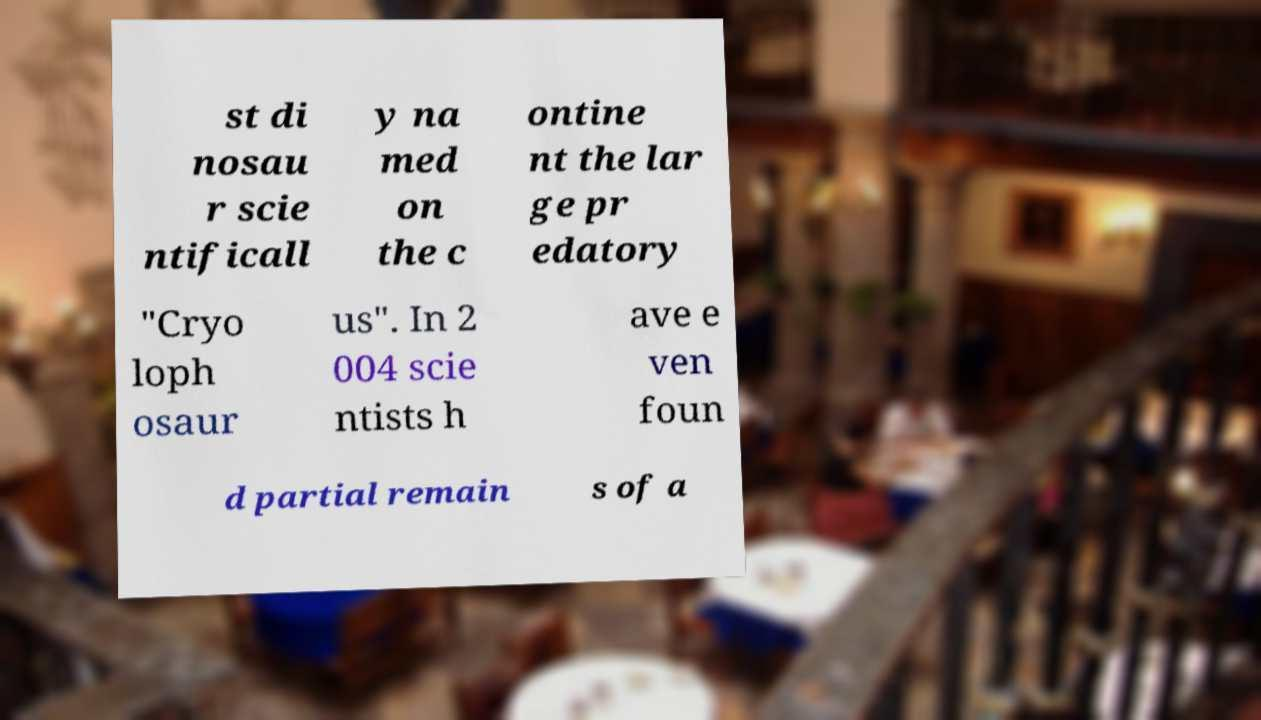I need the written content from this picture converted into text. Can you do that? st di nosau r scie ntificall y na med on the c ontine nt the lar ge pr edatory "Cryo loph osaur us". In 2 004 scie ntists h ave e ven foun d partial remain s of a 